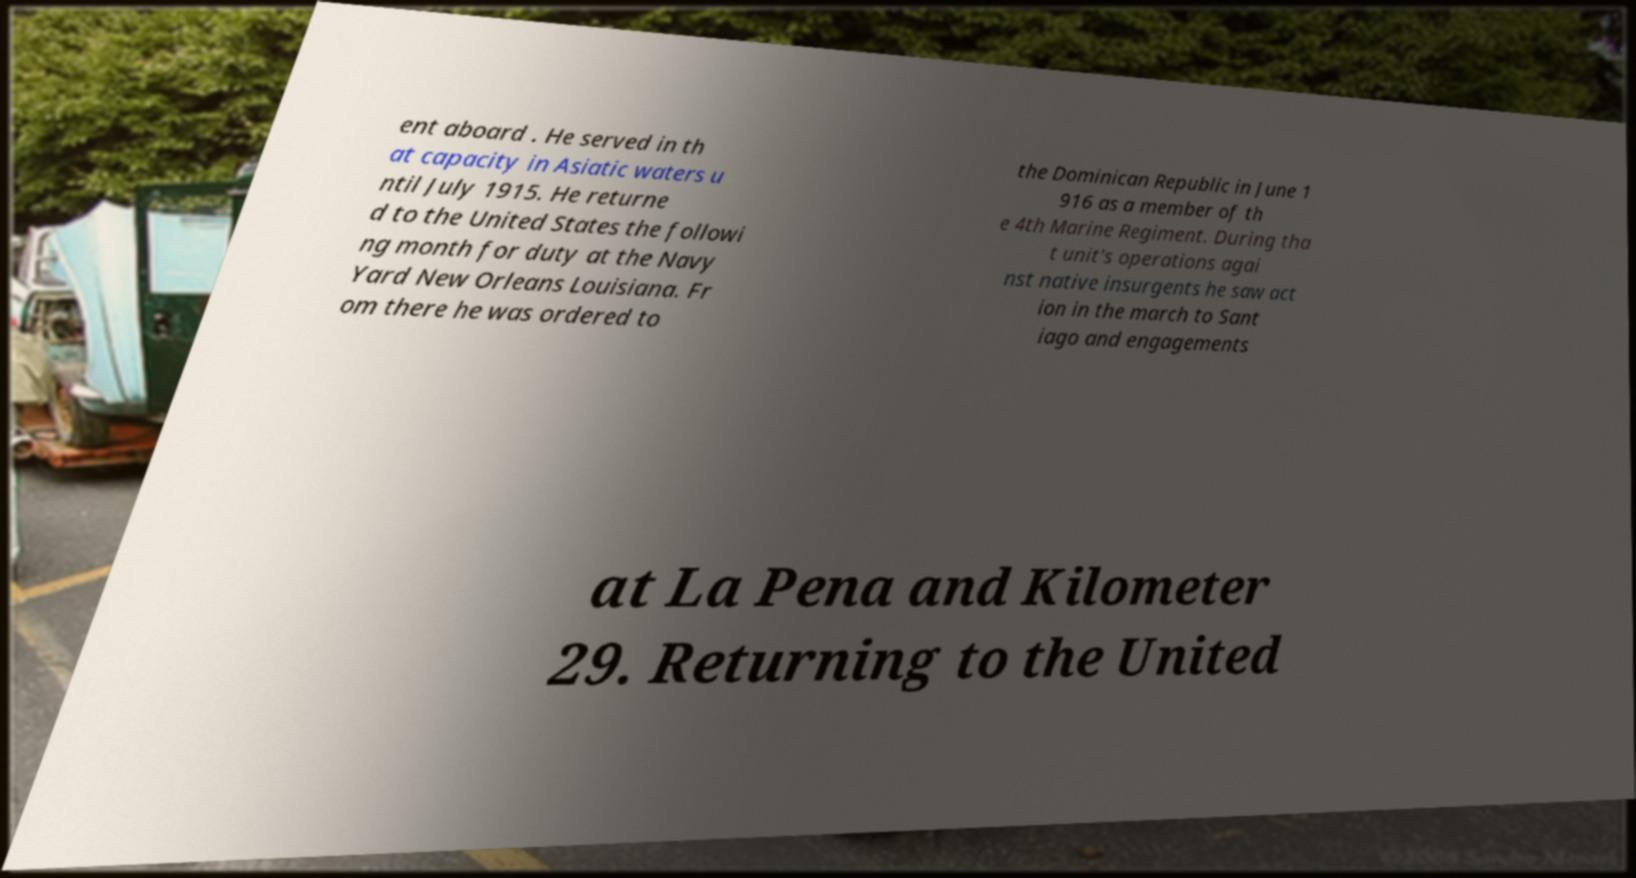Could you extract and type out the text from this image? ent aboard . He served in th at capacity in Asiatic waters u ntil July 1915. He returne d to the United States the followi ng month for duty at the Navy Yard New Orleans Louisiana. Fr om there he was ordered to the Dominican Republic in June 1 916 as a member of th e 4th Marine Regiment. During tha t unit's operations agai nst native insurgents he saw act ion in the march to Sant iago and engagements at La Pena and Kilometer 29. Returning to the United 